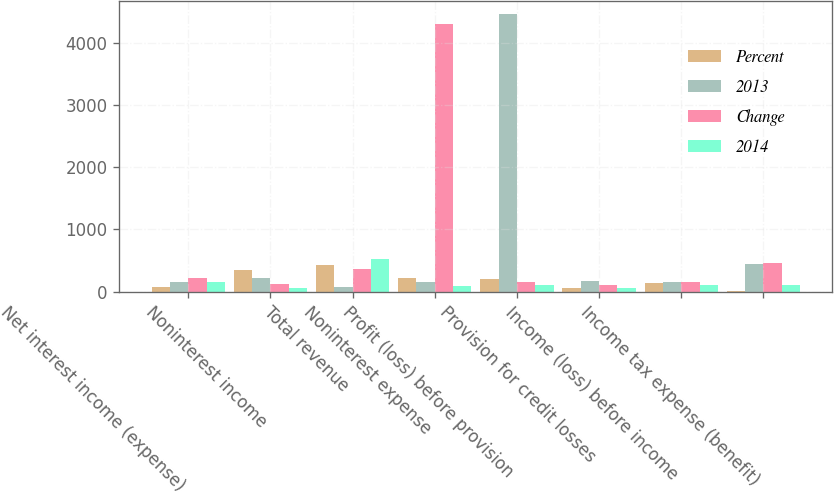Convert chart to OTSL. <chart><loc_0><loc_0><loc_500><loc_500><stacked_bar_chart><ecel><fcel>Net interest income (expense)<fcel>Noninterest income<fcel>Total revenue<fcel>Noninterest expense<fcel>Profit (loss) before provision<fcel>Provision for credit losses<fcel>Income (loss) before income<fcel>Income tax expense (benefit)<nl><fcel>Percent<fcel>77<fcel>350<fcel>427<fcel>227<fcel>200<fcel>66<fcel>134<fcel>12<nl><fcel>2013<fcel>149<fcel>218<fcel>69<fcel>150.5<fcel>4453<fcel>178<fcel>150.5<fcel>449<nl><fcel>Change<fcel>226<fcel>132<fcel>358<fcel>4295<fcel>150.5<fcel>112<fcel>150.5<fcel>461<nl><fcel>2014<fcel>152<fcel>61<fcel>519<fcel>95<fcel>104<fcel>63<fcel>103<fcel>103<nl></chart> 